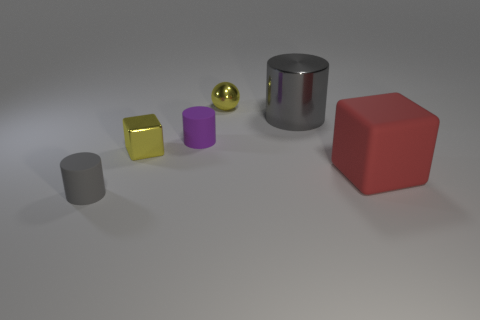Subtract all tiny cylinders. How many cylinders are left? 1 Add 2 big purple shiny things. How many objects exist? 8 Subtract all cyan cylinders. Subtract all gray balls. How many cylinders are left? 3 Subtract all spheres. How many objects are left? 5 Subtract all big red things. Subtract all purple cylinders. How many objects are left? 4 Add 4 tiny yellow shiny things. How many tiny yellow shiny things are left? 6 Add 1 small yellow blocks. How many small yellow blocks exist? 2 Subtract 0 brown blocks. How many objects are left? 6 